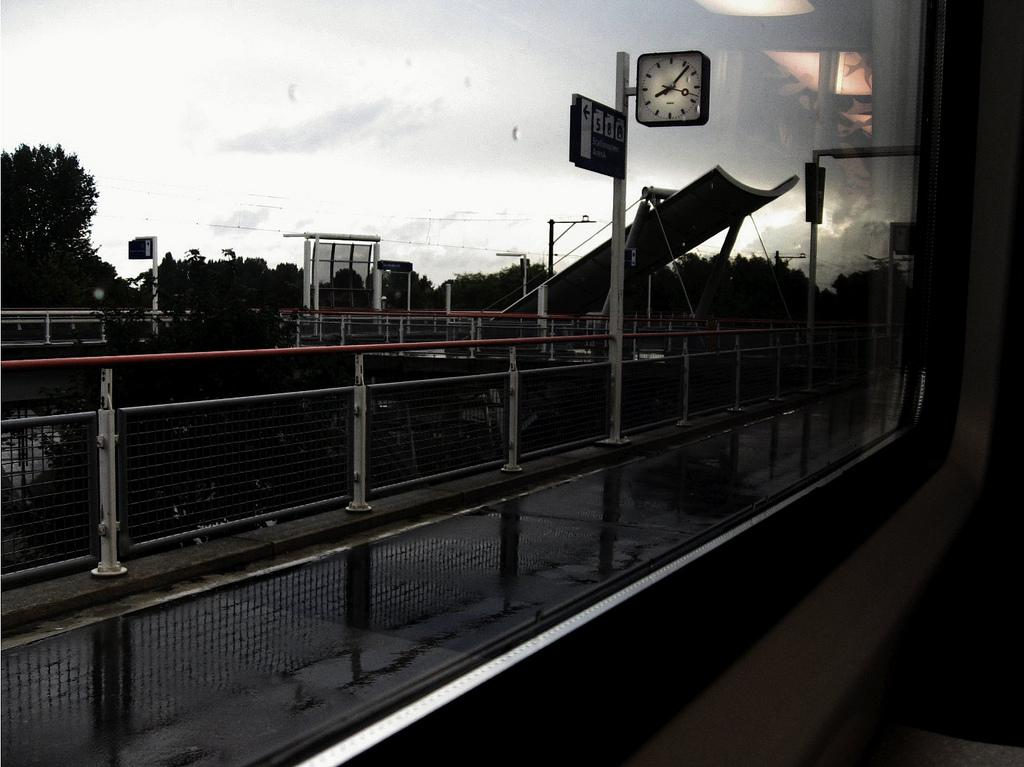Question: when was the photo taken?
Choices:
A. Today.
B. Yesterday.
C. In the evening.
D. In the morning.
Answer with the letter. Answer: D Question: what does the clock read?
Choices:
A. 12 min past 8.
B. 15 min to 2.
C. One thirty-eight.
D. Quarter to 3.
Answer with the letter. Answer: A Question: what is in the background?
Choices:
A. Grass.
B. Trees.
C. The moon.
D. Cars.
Answer with the letter. Answer: B Question: who is in the photo?
Choices:
A. Children.
B. People.
C. Animals.
D. No one.
Answer with the letter. Answer: D Question: why is the ground wet?
Choices:
A. It has been raining.
B. The kids where playing with water.
C. The hose broke.
D. The water pipe broke.
Answer with the letter. Answer: A Question: where is this picture taken?
Choices:
A. A book shop.
B. A club.
C. A train stop.
D. The mall.
Answer with the letter. Answer: C Question: what are the square lights in the sky?
Choices:
A. Lights inside the train, reflected on the window.
B. Stars.
C. Airplane lights.
D. Firecracker lights.
Answer with the letter. Answer: A Question: where was the picture taken from?
Choices:
A. Inside the train.
B. Inside the house.
C. Inside the store.
D. Inside the kitchen.
Answer with the letter. Answer: A Question: what time shows on the clock?
Choices:
A. 10:30 am.
B. 8:06.
C. 5:00 pm.
D. 23:24.
Answer with the letter. Answer: B Question: where does the clock sit?
Choices:
A. On top of the pole with the sign on it.
B. On the floor in the clock tower.
C. On the nightstand.
D. On the TV.
Answer with the letter. Answer: A Question: what type of barricade enclosed the platform?
Choices:
A. Orange sawhorses.
B. A fence like barricade.
C. Concrete barriers.
D. A row of policemen.
Answer with the letter. Answer: B Question: when is the photo taken?
Choices:
A. Christmas morning.
B. Fourth of July.
C. New Years Eve.
D. About evening time.
Answer with the letter. Answer: D Question: why is it dark out?
Choices:
A. It is midnight.
B. It's evening.
C. It is before sunrise.
D. The street lights are out.
Answer with the letter. Answer: B Question: what has green leaves?
Choices:
A. Stem.
B. Green tea.
C. Trees.
D. Leaves.
Answer with the letter. Answer: C Question: what has no numbers?
Choices:
A. Fan.
B. Table.
C. Chair.
D. Clock.
Answer with the letter. Answer: D Question: what sits next to clock?
Choices:
A. Window.
B. Sign with an arrow.
C. Door.
D. Path.
Answer with the letter. Answer: B Question: who is at the scene?
Choices:
A. The police.
B. No one.
C. Construction workers.
D. A man in a business suit.
Answer with the letter. Answer: B 